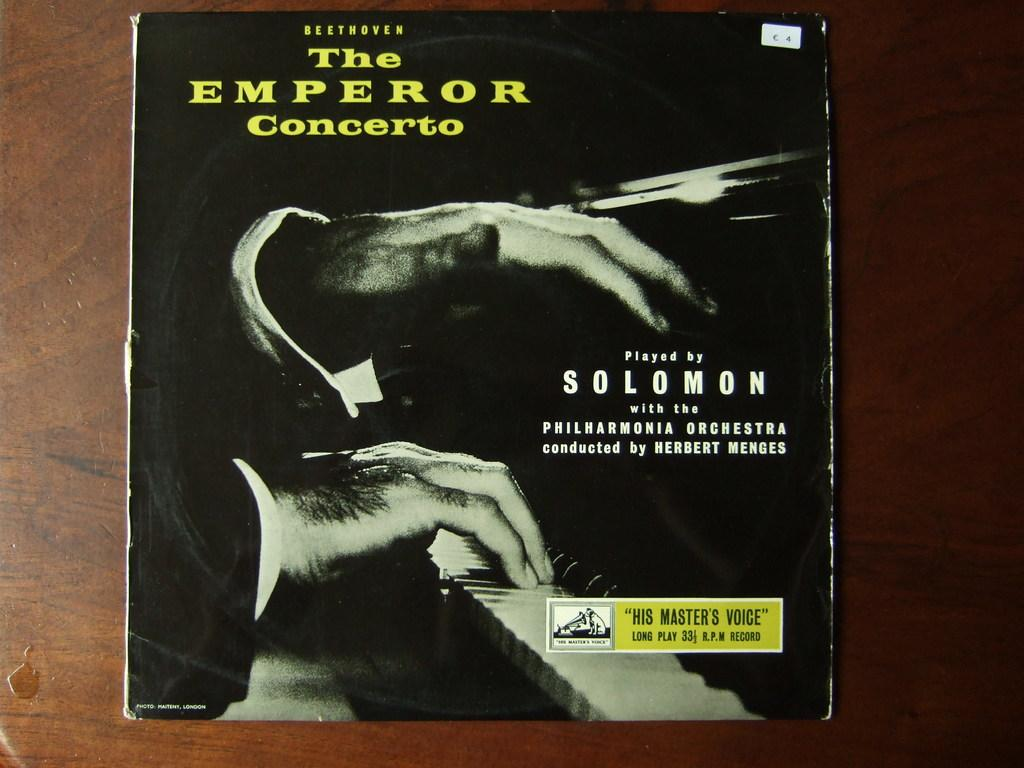<image>
Relay a brief, clear account of the picture shown. A record titled The Emperor Concerto played by Solomon 